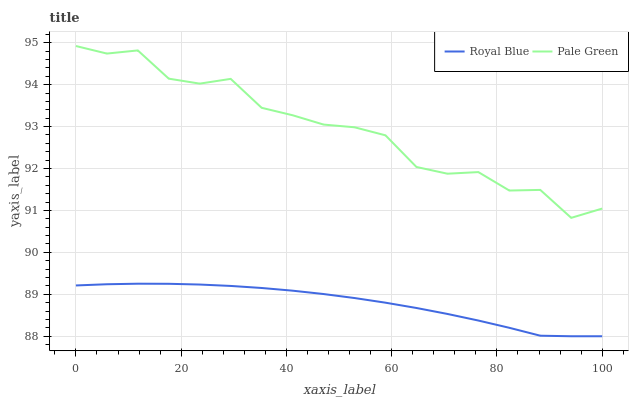Does Royal Blue have the minimum area under the curve?
Answer yes or no. Yes. Does Pale Green have the maximum area under the curve?
Answer yes or no. Yes. Does Pale Green have the minimum area under the curve?
Answer yes or no. No. Is Royal Blue the smoothest?
Answer yes or no. Yes. Is Pale Green the roughest?
Answer yes or no. Yes. Is Pale Green the smoothest?
Answer yes or no. No. Does Royal Blue have the lowest value?
Answer yes or no. Yes. Does Pale Green have the lowest value?
Answer yes or no. No. Does Pale Green have the highest value?
Answer yes or no. Yes. Is Royal Blue less than Pale Green?
Answer yes or no. Yes. Is Pale Green greater than Royal Blue?
Answer yes or no. Yes. Does Royal Blue intersect Pale Green?
Answer yes or no. No. 